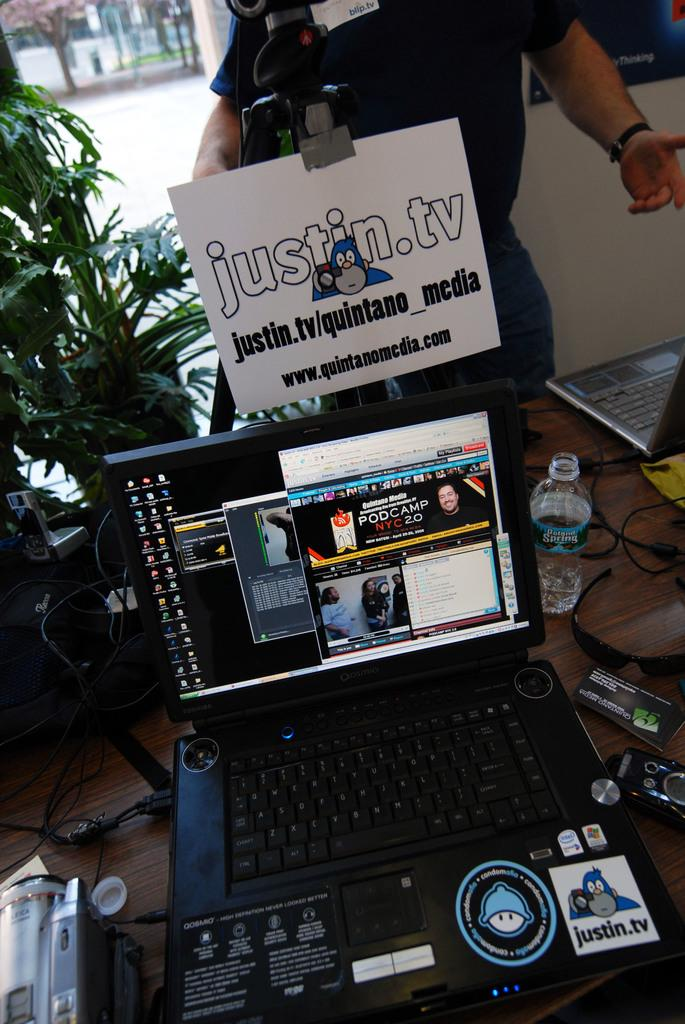What is the main subject in the image? There is a person standing in the image. What is in front of the person? There is a laptop and a bottle in front of the person. What can be seen on the table? There are objects on the table. What is the color of the plant in the image? The plant in the image is green in color. Where is the park located in the image? There is no park present in the image. What type of coach can be seen in the image? There is no coach present in the image. 